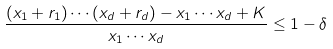<formula> <loc_0><loc_0><loc_500><loc_500>\frac { ( x _ { 1 } + r _ { 1 } ) \cdots ( x _ { d } + r _ { d } ) - x _ { 1 } \cdots x _ { d } + K } { x _ { 1 } \cdots x _ { d } } \leq 1 - \delta</formula> 